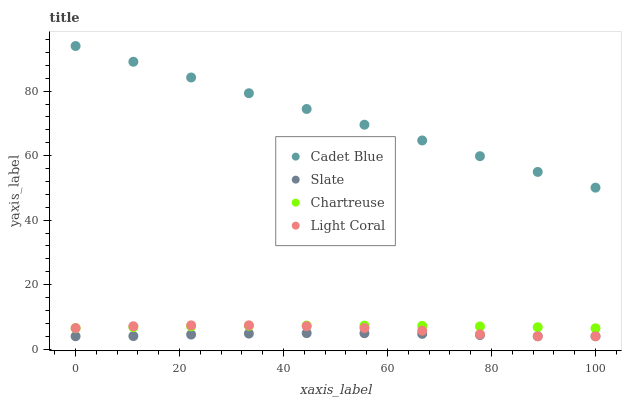Does Slate have the minimum area under the curve?
Answer yes or no. Yes. Does Cadet Blue have the maximum area under the curve?
Answer yes or no. Yes. Does Cadet Blue have the minimum area under the curve?
Answer yes or no. No. Does Slate have the maximum area under the curve?
Answer yes or no. No. Is Cadet Blue the smoothest?
Answer yes or no. Yes. Is Light Coral the roughest?
Answer yes or no. Yes. Is Slate the smoothest?
Answer yes or no. No. Is Slate the roughest?
Answer yes or no. No. Does Light Coral have the lowest value?
Answer yes or no. Yes. Does Cadet Blue have the lowest value?
Answer yes or no. No. Does Cadet Blue have the highest value?
Answer yes or no. Yes. Does Slate have the highest value?
Answer yes or no. No. Is Light Coral less than Cadet Blue?
Answer yes or no. Yes. Is Cadet Blue greater than Slate?
Answer yes or no. Yes. Does Chartreuse intersect Light Coral?
Answer yes or no. Yes. Is Chartreuse less than Light Coral?
Answer yes or no. No. Is Chartreuse greater than Light Coral?
Answer yes or no. No. Does Light Coral intersect Cadet Blue?
Answer yes or no. No. 